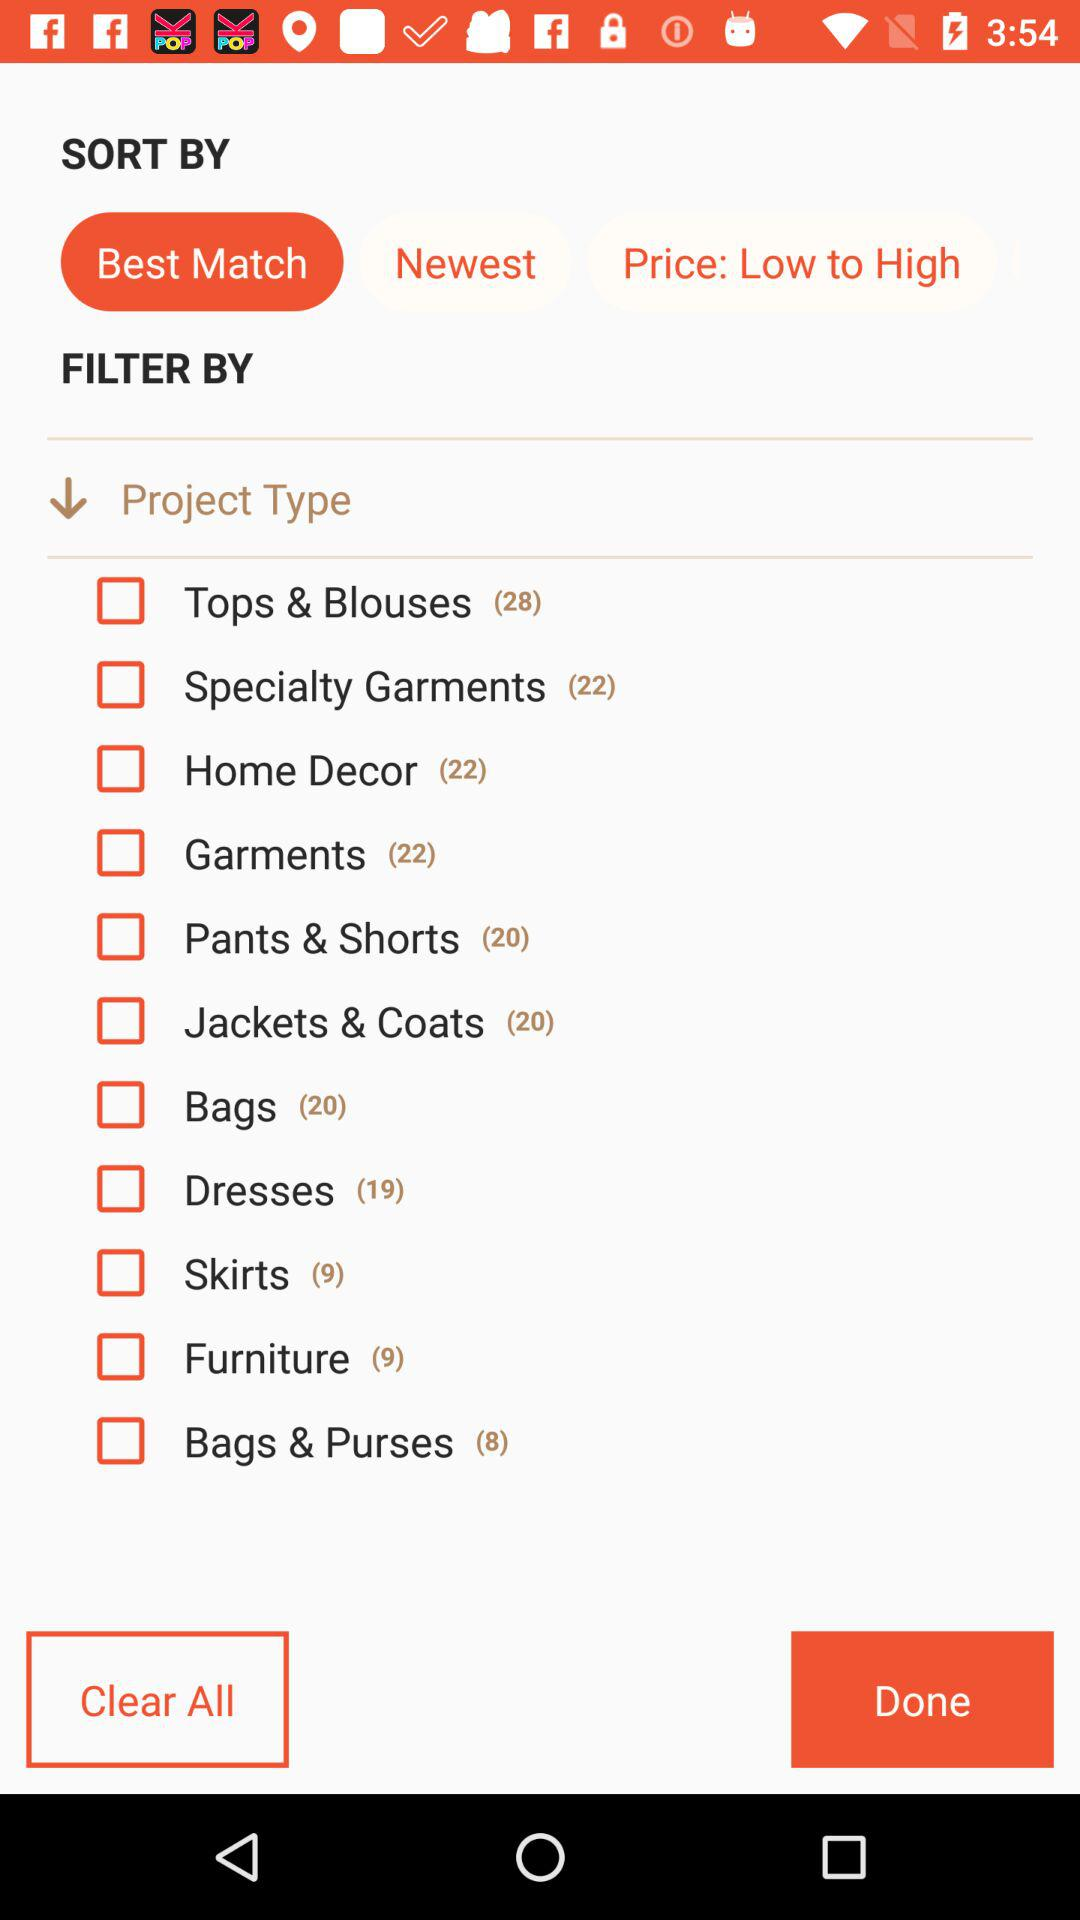What is the number shown in "Pants & Shorts"? The shown number is 20. 